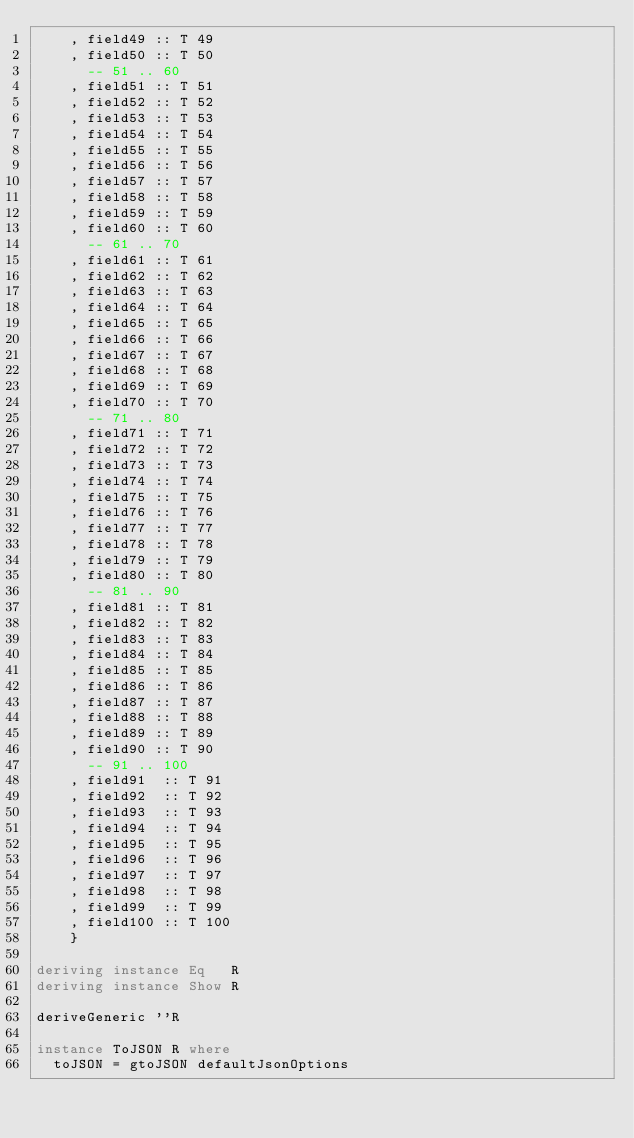<code> <loc_0><loc_0><loc_500><loc_500><_Haskell_>    , field49 :: T 49
    , field50 :: T 50
      -- 51 .. 60
    , field51 :: T 51
    , field52 :: T 52
    , field53 :: T 53
    , field54 :: T 54
    , field55 :: T 55
    , field56 :: T 56
    , field57 :: T 57
    , field58 :: T 58
    , field59 :: T 59
    , field60 :: T 60
      -- 61 .. 70
    , field61 :: T 61
    , field62 :: T 62
    , field63 :: T 63
    , field64 :: T 64
    , field65 :: T 65
    , field66 :: T 66
    , field67 :: T 67
    , field68 :: T 68
    , field69 :: T 69
    , field70 :: T 70
      -- 71 .. 80
    , field71 :: T 71
    , field72 :: T 72
    , field73 :: T 73
    , field74 :: T 74
    , field75 :: T 75
    , field76 :: T 76
    , field77 :: T 77
    , field78 :: T 78
    , field79 :: T 79
    , field80 :: T 80
      -- 81 .. 90
    , field81 :: T 81
    , field82 :: T 82
    , field83 :: T 83
    , field84 :: T 84
    , field85 :: T 85
    , field86 :: T 86
    , field87 :: T 87
    , field88 :: T 88
    , field89 :: T 89
    , field90 :: T 90
      -- 91 .. 100
    , field91  :: T 91
    , field92  :: T 92
    , field93  :: T 93
    , field94  :: T 94
    , field95  :: T 95
    , field96  :: T 96
    , field97  :: T 97
    , field98  :: T 98
    , field99  :: T 99
    , field100 :: T 100
    }

deriving instance Eq   R
deriving instance Show R

deriveGeneric ''R

instance ToJSON R where
  toJSON = gtoJSON defaultJsonOptions
</code> 